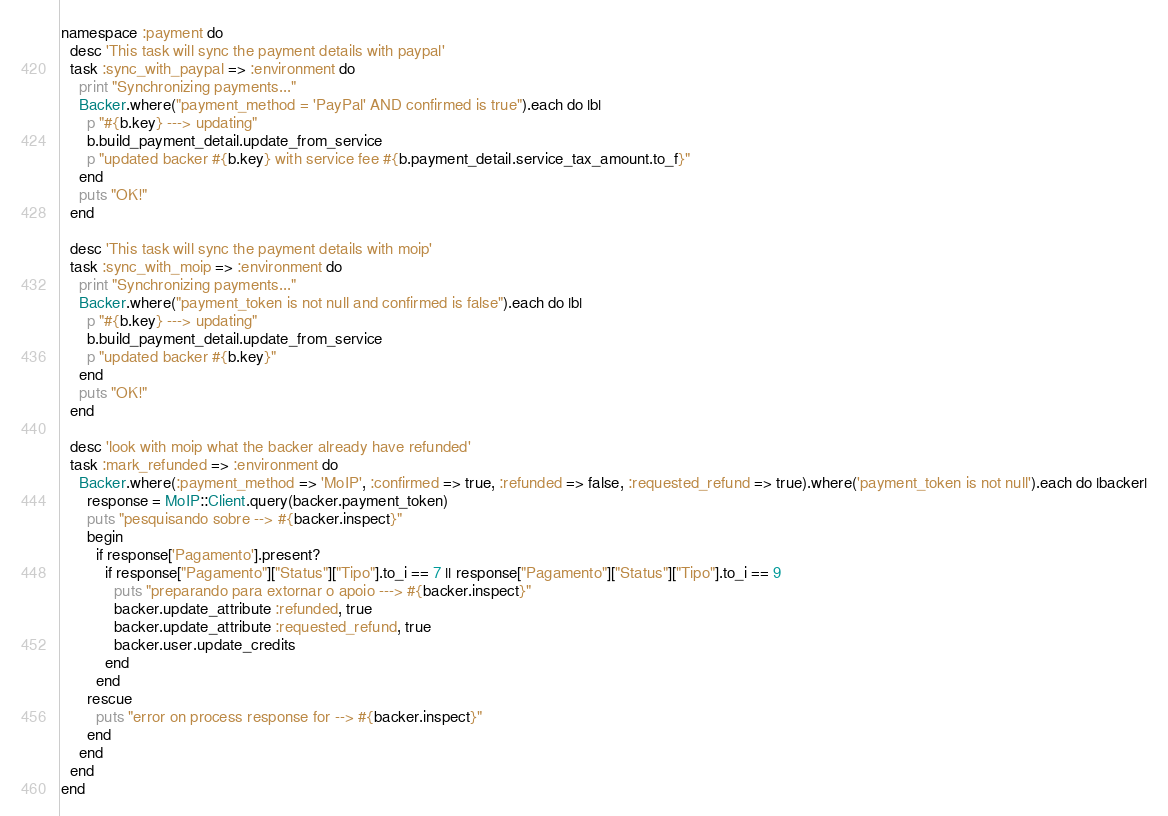<code> <loc_0><loc_0><loc_500><loc_500><_Ruby_>namespace :payment do
  desc 'This task will sync the payment details with paypal'
  task :sync_with_paypal => :environment do
    print "Synchronizing payments..."
    Backer.where("payment_method = 'PayPal' AND confirmed is true").each do |b|
      p "#{b.key} ---> updating"
      b.build_payment_detail.update_from_service
      p "updated backer #{b.key} with service fee #{b.payment_detail.service_tax_amount.to_f}"
    end
    puts "OK!"
  end

  desc 'This task will sync the payment details with moip'
  task :sync_with_moip => :environment do
    print "Synchronizing payments..."
    Backer.where("payment_token is not null and confirmed is false").each do |b|
      p "#{b.key} ---> updating"
      b.build_payment_detail.update_from_service
      p "updated backer #{b.key}"
    end
    puts "OK!"
  end

  desc 'look with moip what the backer already have refunded'
  task :mark_refunded => :environment do
    Backer.where(:payment_method => 'MoIP', :confirmed => true, :refunded => false, :requested_refund => true).where('payment_token is not null').each do |backer|
      response = MoIP::Client.query(backer.payment_token)
      puts "pesquisando sobre --> #{backer.inspect}"
      begin
        if response['Pagamento'].present?
          if response["Pagamento"]["Status"]["Tipo"].to_i == 7 || response["Pagamento"]["Status"]["Tipo"].to_i == 9
            puts "preparando para extornar o apoio ---> #{backer.inspect}"
            backer.update_attribute :refunded, true
            backer.update_attribute :requested_refund, true
            backer.user.update_credits
          end
        end
      rescue
        puts "error on process response for --> #{backer.inspect}"
      end
    end
  end
end
</code> 